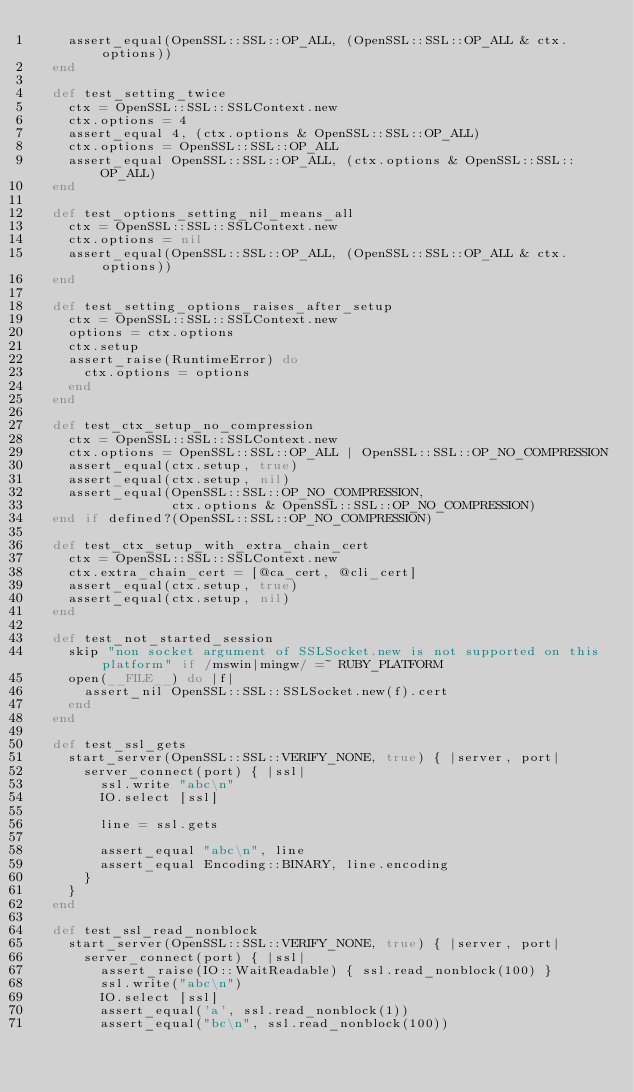Convert code to text. <code><loc_0><loc_0><loc_500><loc_500><_Ruby_>    assert_equal(OpenSSL::SSL::OP_ALL, (OpenSSL::SSL::OP_ALL & ctx.options))
  end

  def test_setting_twice
    ctx = OpenSSL::SSL::SSLContext.new
    ctx.options = 4
    assert_equal 4, (ctx.options & OpenSSL::SSL::OP_ALL)
    ctx.options = OpenSSL::SSL::OP_ALL
    assert_equal OpenSSL::SSL::OP_ALL, (ctx.options & OpenSSL::SSL::OP_ALL)
  end

  def test_options_setting_nil_means_all
    ctx = OpenSSL::SSL::SSLContext.new
    ctx.options = nil
    assert_equal(OpenSSL::SSL::OP_ALL, (OpenSSL::SSL::OP_ALL & ctx.options))
  end

  def test_setting_options_raises_after_setup
    ctx = OpenSSL::SSL::SSLContext.new
    options = ctx.options
    ctx.setup
    assert_raise(RuntimeError) do
      ctx.options = options
    end
  end

  def test_ctx_setup_no_compression
    ctx = OpenSSL::SSL::SSLContext.new
    ctx.options = OpenSSL::SSL::OP_ALL | OpenSSL::SSL::OP_NO_COMPRESSION
    assert_equal(ctx.setup, true)
    assert_equal(ctx.setup, nil)
    assert_equal(OpenSSL::SSL::OP_NO_COMPRESSION,
                 ctx.options & OpenSSL::SSL::OP_NO_COMPRESSION)
  end if defined?(OpenSSL::SSL::OP_NO_COMPRESSION)

  def test_ctx_setup_with_extra_chain_cert
    ctx = OpenSSL::SSL::SSLContext.new
    ctx.extra_chain_cert = [@ca_cert, @cli_cert]
    assert_equal(ctx.setup, true)
    assert_equal(ctx.setup, nil)
  end

  def test_not_started_session
    skip "non socket argument of SSLSocket.new is not supported on this platform" if /mswin|mingw/ =~ RUBY_PLATFORM
    open(__FILE__) do |f|
      assert_nil OpenSSL::SSL::SSLSocket.new(f).cert
    end
  end

  def test_ssl_gets
    start_server(OpenSSL::SSL::VERIFY_NONE, true) { |server, port|
      server_connect(port) { |ssl|
        ssl.write "abc\n"
        IO.select [ssl]

        line = ssl.gets

        assert_equal "abc\n", line
        assert_equal Encoding::BINARY, line.encoding
      }
    }
  end

  def test_ssl_read_nonblock
    start_server(OpenSSL::SSL::VERIFY_NONE, true) { |server, port|
      server_connect(port) { |ssl|
        assert_raise(IO::WaitReadable) { ssl.read_nonblock(100) }
        ssl.write("abc\n")
        IO.select [ssl]
        assert_equal('a', ssl.read_nonblock(1))
        assert_equal("bc\n", ssl.read_nonblock(100))</code> 